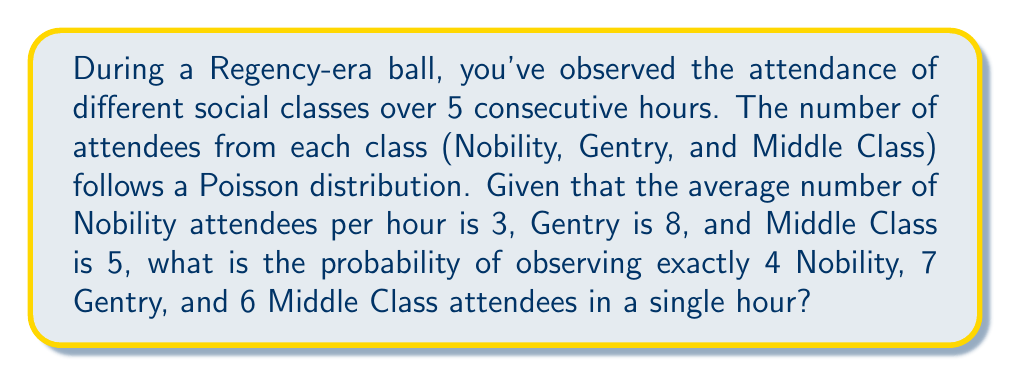Show me your answer to this math problem. To solve this problem, we need to use the Poisson distribution formula for each social class and then multiply the probabilities together.

The Poisson distribution formula is:

$$P(X = k) = \frac{e^{-\lambda}\lambda^k}{k!}$$

Where:
$\lambda$ is the average number of events per interval
$k$ is the number of events we're calculating the probability for
$e$ is Euler's number (approximately 2.71828)

Step 1: Calculate the probability for Nobility (λ = 3, k = 4)
$$P(X_N = 4) = \frac{e^{-3}3^4}{4!} = \frac{e^{-3}81}{24} \approx 0.1680$$

Step 2: Calculate the probability for Gentry (λ = 8, k = 7)
$$P(X_G = 7) = \frac{e^{-8}8^7}{7!} = \frac{e^{-8}2097152}{5040} \approx 0.1396$$

Step 3: Calculate the probability for Middle Class (λ = 5, k = 6)
$$P(X_M = 6) = \frac{e^{-5}5^6}{6!} = \frac{e^{-5}15625}{720} \approx 0.1606$$

Step 4: Multiply the probabilities together to get the joint probability
$$P(\text{4 Nobility, 7 Gentry, 6 Middle Class}) = 0.1680 \times 0.1396 \times 0.1606 \approx 0.00377$$
Answer: 0.00377 